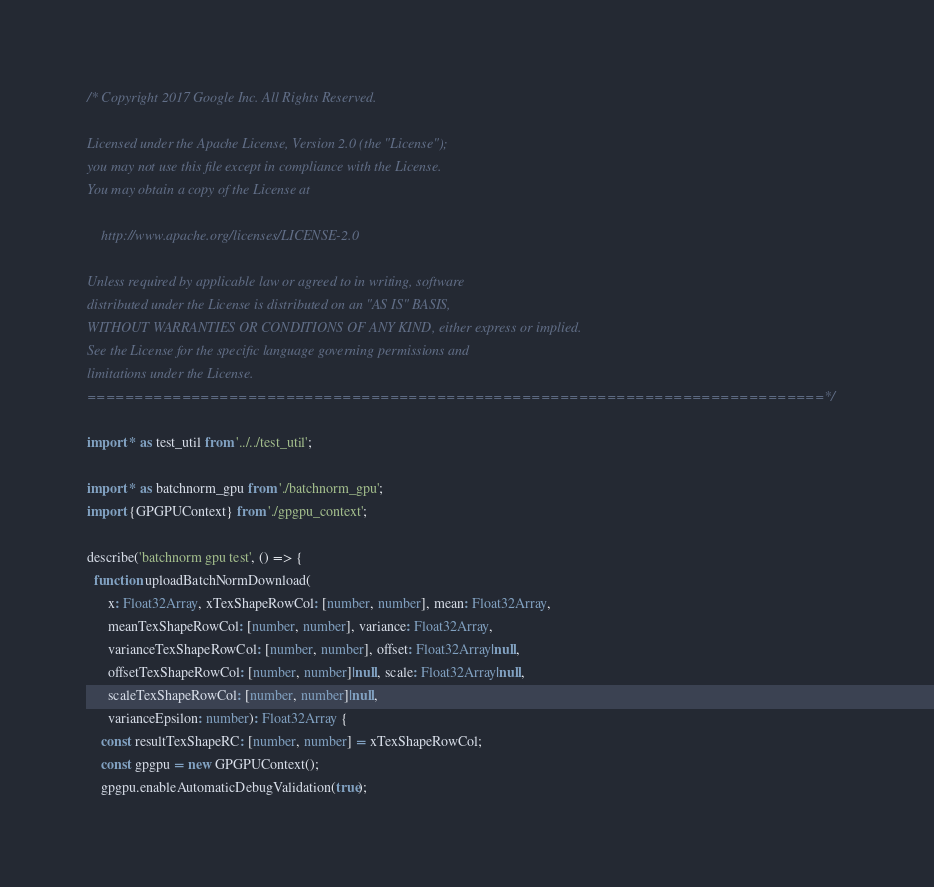Convert code to text. <code><loc_0><loc_0><loc_500><loc_500><_TypeScript_>/* Copyright 2017 Google Inc. All Rights Reserved.

Licensed under the Apache License, Version 2.0 (the "License");
you may not use this file except in compliance with the License.
You may obtain a copy of the License at

    http://www.apache.org/licenses/LICENSE-2.0

Unless required by applicable law or agreed to in writing, software
distributed under the License is distributed on an "AS IS" BASIS,
WITHOUT WARRANTIES OR CONDITIONS OF ANY KIND, either express or implied.
See the License for the specific language governing permissions and
limitations under the License.
==============================================================================*/

import * as test_util from '../../test_util';

import * as batchnorm_gpu from './batchnorm_gpu';
import {GPGPUContext} from './gpgpu_context';

describe('batchnorm gpu test', () => {
  function uploadBatchNormDownload(
      x: Float32Array, xTexShapeRowCol: [number, number], mean: Float32Array,
      meanTexShapeRowCol: [number, number], variance: Float32Array,
      varianceTexShapeRowCol: [number, number], offset: Float32Array|null,
      offsetTexShapeRowCol: [number, number]|null, scale: Float32Array|null,
      scaleTexShapeRowCol: [number, number]|null,
      varianceEpsilon: number): Float32Array {
    const resultTexShapeRC: [number, number] = xTexShapeRowCol;
    const gpgpu = new GPGPUContext();
    gpgpu.enableAutomaticDebugValidation(true);
</code> 